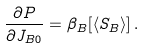Convert formula to latex. <formula><loc_0><loc_0><loc_500><loc_500>\frac { \partial P } { \partial J _ { B 0 } } = \beta _ { B } [ \langle S _ { B } \rangle ] \, .</formula> 